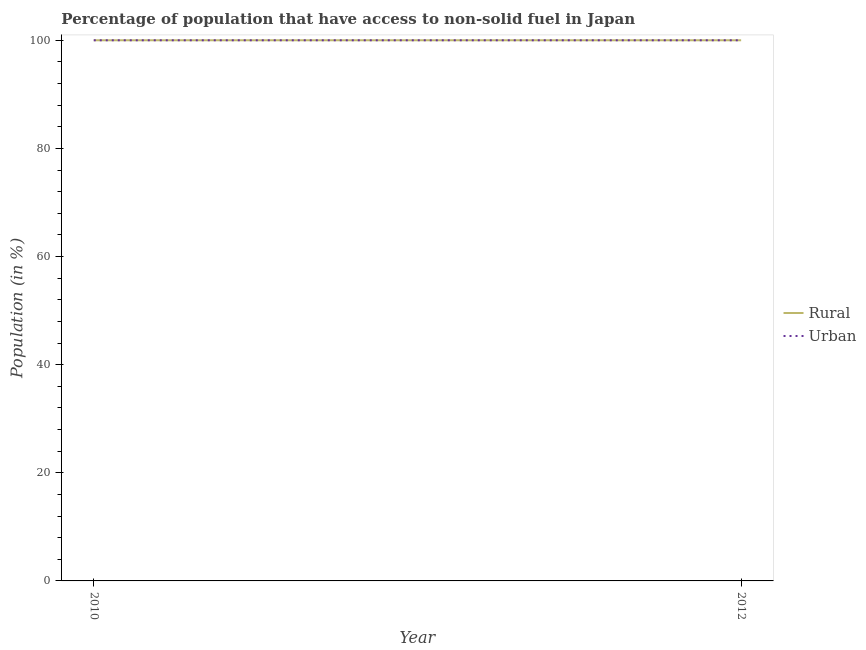Does the line corresponding to rural population intersect with the line corresponding to urban population?
Your answer should be very brief. Yes. Is the number of lines equal to the number of legend labels?
Your response must be concise. Yes. What is the rural population in 2012?
Your response must be concise. 100. Across all years, what is the maximum urban population?
Your answer should be compact. 100. Across all years, what is the minimum rural population?
Provide a short and direct response. 100. What is the total rural population in the graph?
Your answer should be compact. 200. What is the difference between the rural population in 2010 and that in 2012?
Offer a terse response. 0. What is the difference between the rural population in 2012 and the urban population in 2010?
Your answer should be very brief. 0. What is the ratio of the rural population in 2010 to that in 2012?
Offer a terse response. 1. In how many years, is the urban population greater than the average urban population taken over all years?
Your answer should be compact. 0. Does the rural population monotonically increase over the years?
Offer a very short reply. No. Is the rural population strictly less than the urban population over the years?
Provide a succinct answer. No. What is the difference between two consecutive major ticks on the Y-axis?
Ensure brevity in your answer.  20. Are the values on the major ticks of Y-axis written in scientific E-notation?
Provide a short and direct response. No. Does the graph contain grids?
Give a very brief answer. No. How many legend labels are there?
Offer a terse response. 2. How are the legend labels stacked?
Provide a succinct answer. Vertical. What is the title of the graph?
Give a very brief answer. Percentage of population that have access to non-solid fuel in Japan. Does "Highest 20% of population" appear as one of the legend labels in the graph?
Your response must be concise. No. What is the label or title of the X-axis?
Offer a very short reply. Year. What is the Population (in %) in Rural in 2010?
Provide a succinct answer. 100. What is the total Population (in %) in Rural in the graph?
Give a very brief answer. 200. What is the total Population (in %) in Urban in the graph?
Give a very brief answer. 200. What is the difference between the Population (in %) of Urban in 2010 and that in 2012?
Make the answer very short. 0. What is the difference between the Population (in %) in Rural in 2010 and the Population (in %) in Urban in 2012?
Ensure brevity in your answer.  0. In the year 2010, what is the difference between the Population (in %) of Rural and Population (in %) of Urban?
Offer a terse response. 0. In the year 2012, what is the difference between the Population (in %) in Rural and Population (in %) in Urban?
Your answer should be compact. 0. What is the difference between the highest and the second highest Population (in %) in Rural?
Your response must be concise. 0. What is the difference between the highest and the lowest Population (in %) in Urban?
Offer a very short reply. 0. 